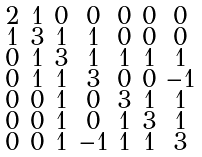Convert formula to latex. <formula><loc_0><loc_0><loc_500><loc_500>\begin{smallmatrix} 2 & 1 & 0 & 0 & 0 & 0 & 0 \\ 1 & 3 & 1 & 1 & 0 & 0 & 0 \\ 0 & 1 & 3 & 1 & 1 & 1 & 1 \\ 0 & 1 & 1 & 3 & 0 & 0 & - 1 \\ 0 & 0 & 1 & 0 & 3 & 1 & 1 \\ 0 & 0 & 1 & 0 & 1 & 3 & 1 \\ 0 & 0 & 1 & - 1 & 1 & 1 & 3 \end{smallmatrix}</formula> 